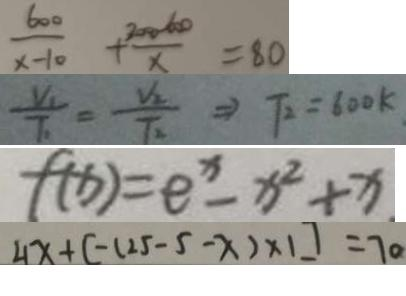Convert formula to latex. <formula><loc_0><loc_0><loc_500><loc_500>\frac { 6 0 0 } { x - 1 0 } + \frac { 3 0 0 0 - 6 0 0 } { x } = 8 0 
 \frac { V _ { 1 } } { T _ { 1 } } = \frac { V _ { 2 } } { T _ { 2 } } \Rightarrow T _ { 2 } = 6 0 0 k . 
 f ( x ) = e ^ { x } - x ^ { 2 } + x 
 4 x + [ - ( - 2 5 - 5 - x ) \times 1 ] = 7 0</formula> 